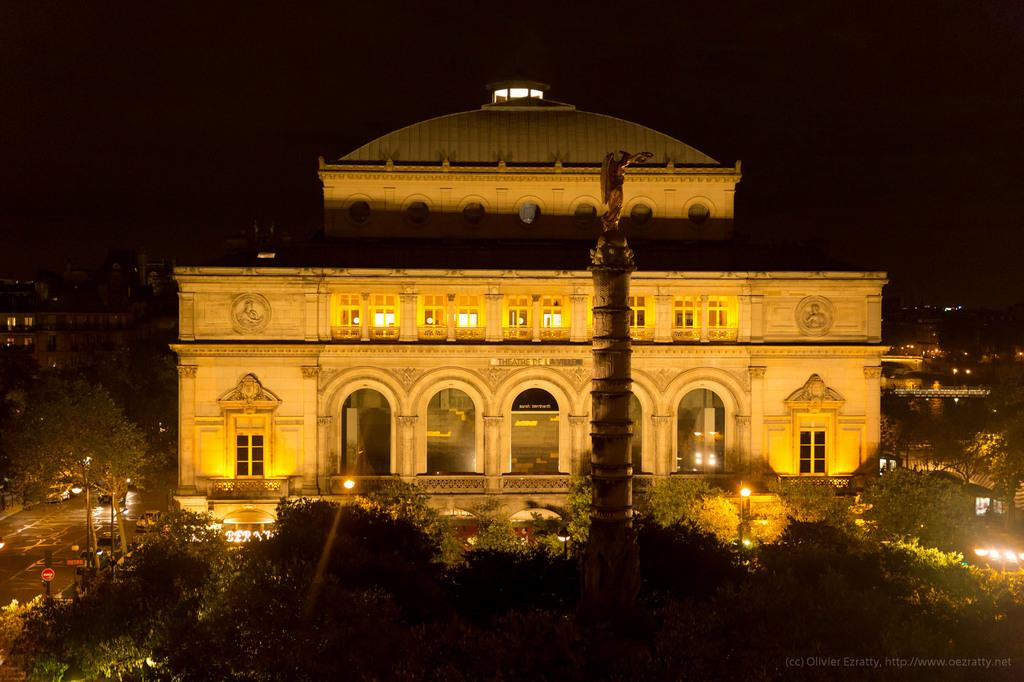What type of structures can be seen in the image? There are buildings with windows in the image, as well as a tower. What else can be seen on the ground in the image? There are vehicles on the road in the image. What natural elements are present in the image? There is a group of trees in the image. What artificial elements can be seen in the image? There are lights, poles, and signboards in the image. What part of the natural environment is visible in the image? The sky is visible in the image. Can you see any kites flying in the image? There are no kites visible in the image. What type of fang can be seen on the pole in the image? There are no fangs present in the image; the poles mentioned are likely utility poles or signposts. 